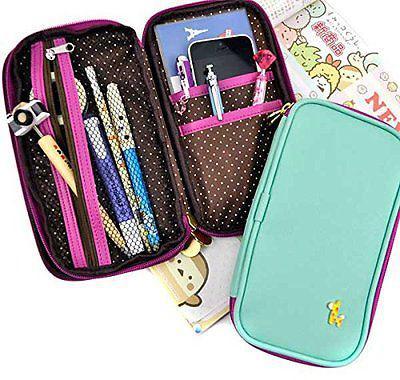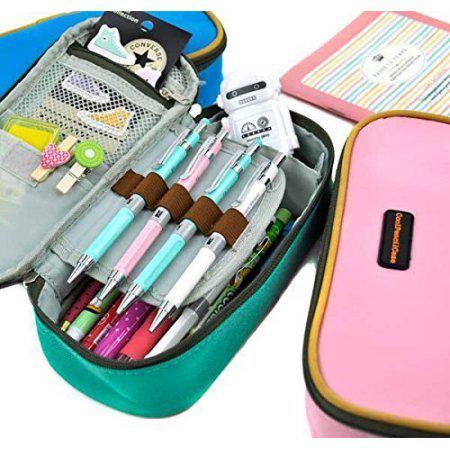The first image is the image on the left, the second image is the image on the right. For the images shown, is this caption "There are no more than two camera pencil toppers in both sets of images." true? Answer yes or no. Yes. The first image is the image on the left, the second image is the image on the right. Examine the images to the left and right. Is the description "Each image includes a closed zipper case to the right of an open, filled pencil case." accurate? Answer yes or no. Yes. 